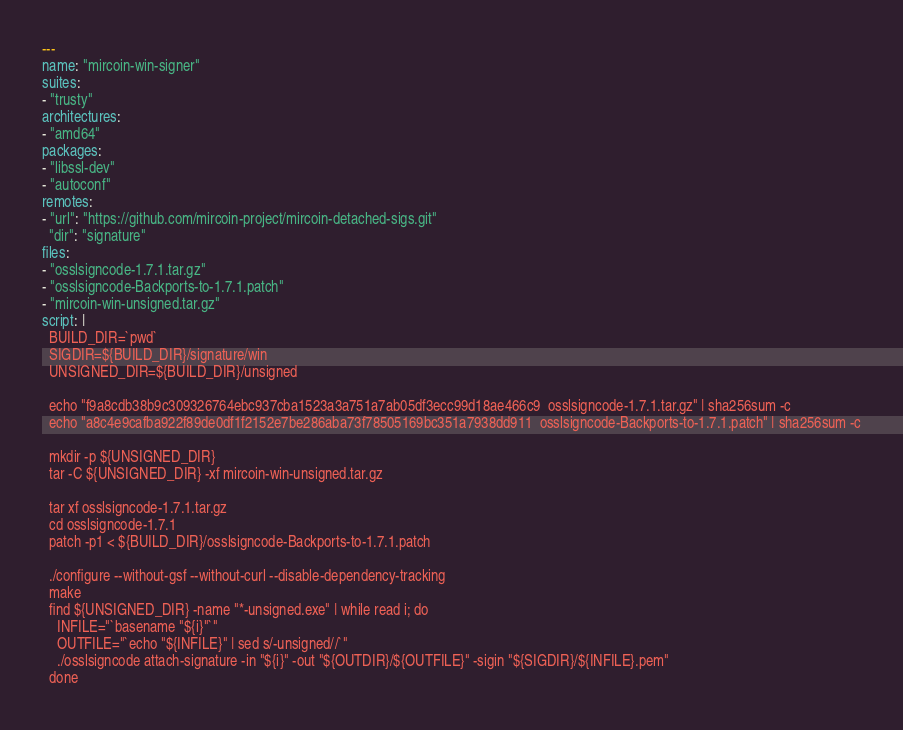Convert code to text. <code><loc_0><loc_0><loc_500><loc_500><_YAML_>---
name: "mircoin-win-signer"
suites:
- "trusty"
architectures:
- "amd64"
packages:
- "libssl-dev"
- "autoconf"
remotes:
- "url": "https://github.com/mircoin-project/mircoin-detached-sigs.git"
  "dir": "signature"
files:
- "osslsigncode-1.7.1.tar.gz"
- "osslsigncode-Backports-to-1.7.1.patch"
- "mircoin-win-unsigned.tar.gz"
script: |
  BUILD_DIR=`pwd`
  SIGDIR=${BUILD_DIR}/signature/win
  UNSIGNED_DIR=${BUILD_DIR}/unsigned

  echo "f9a8cdb38b9c309326764ebc937cba1523a3a751a7ab05df3ecc99d18ae466c9  osslsigncode-1.7.1.tar.gz" | sha256sum -c
  echo "a8c4e9cafba922f89de0df1f2152e7be286aba73f78505169bc351a7938dd911  osslsigncode-Backports-to-1.7.1.patch" | sha256sum -c

  mkdir -p ${UNSIGNED_DIR}
  tar -C ${UNSIGNED_DIR} -xf mircoin-win-unsigned.tar.gz

  tar xf osslsigncode-1.7.1.tar.gz
  cd osslsigncode-1.7.1
  patch -p1 < ${BUILD_DIR}/osslsigncode-Backports-to-1.7.1.patch

  ./configure --without-gsf --without-curl --disable-dependency-tracking
  make
  find ${UNSIGNED_DIR} -name "*-unsigned.exe" | while read i; do
    INFILE="`basename "${i}"`"
    OUTFILE="`echo "${INFILE}" | sed s/-unsigned//`"
    ./osslsigncode attach-signature -in "${i}" -out "${OUTDIR}/${OUTFILE}" -sigin "${SIGDIR}/${INFILE}.pem"
  done
</code> 